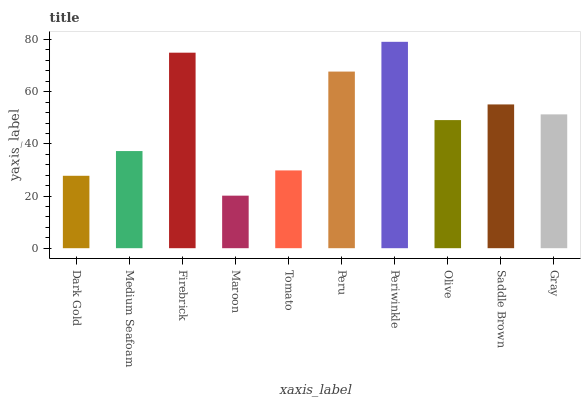Is Maroon the minimum?
Answer yes or no. Yes. Is Periwinkle the maximum?
Answer yes or no. Yes. Is Medium Seafoam the minimum?
Answer yes or no. No. Is Medium Seafoam the maximum?
Answer yes or no. No. Is Medium Seafoam greater than Dark Gold?
Answer yes or no. Yes. Is Dark Gold less than Medium Seafoam?
Answer yes or no. Yes. Is Dark Gold greater than Medium Seafoam?
Answer yes or no. No. Is Medium Seafoam less than Dark Gold?
Answer yes or no. No. Is Gray the high median?
Answer yes or no. Yes. Is Olive the low median?
Answer yes or no. Yes. Is Maroon the high median?
Answer yes or no. No. Is Medium Seafoam the low median?
Answer yes or no. No. 